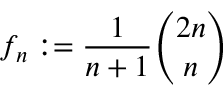Convert formula to latex. <formula><loc_0><loc_0><loc_500><loc_500>f _ { n } \colon = { \frac { 1 } { n + 1 } } { \binom { 2 n } { n } }</formula> 